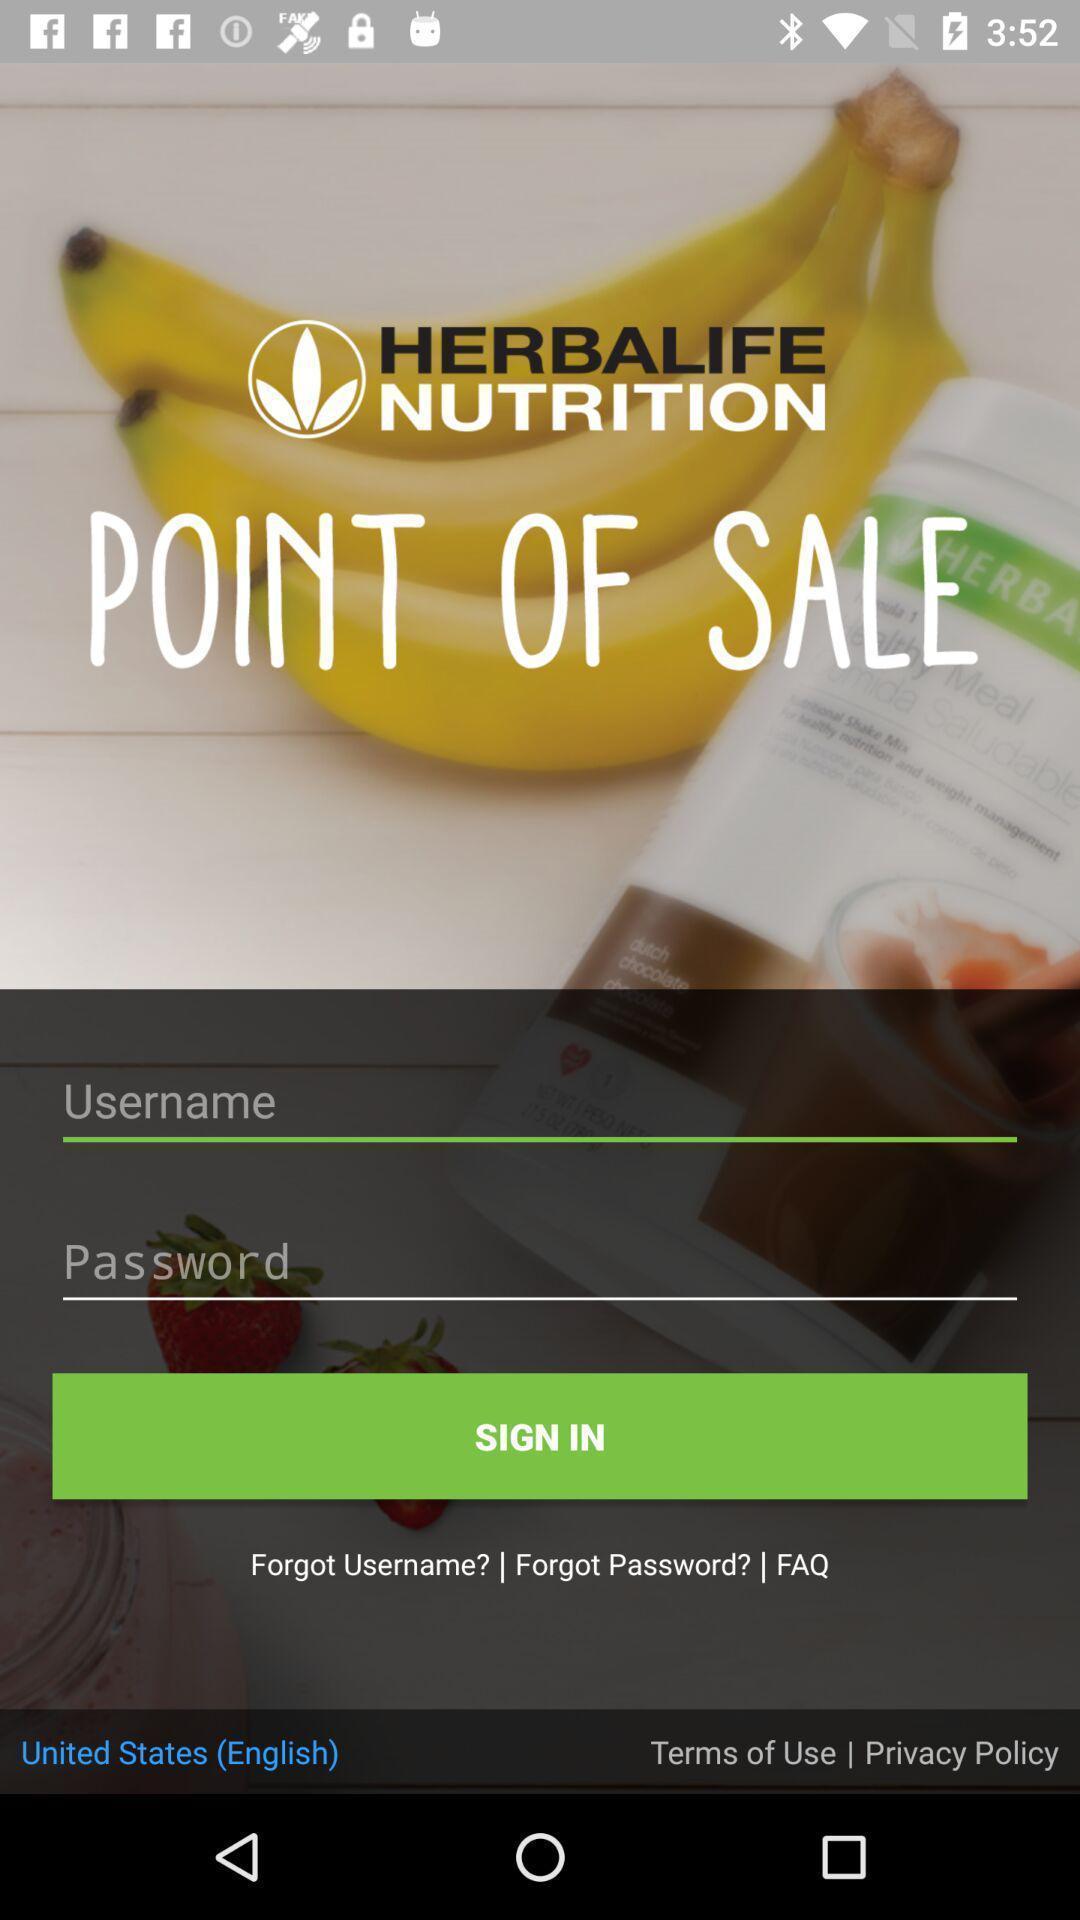Give me a summary of this screen capture. Sign-in page of a healthcare app. 